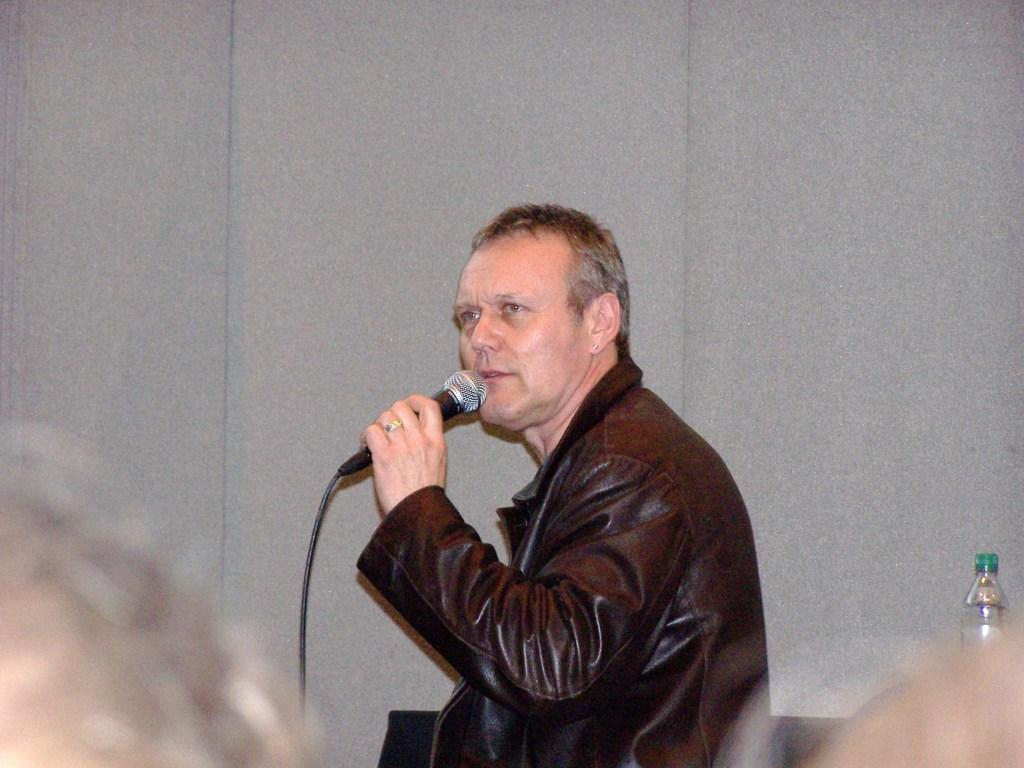Who is present in the image? There is a man in the image. What is the man wearing? The man is wearing a jacket. What object is the man holding in his hand? The man is holding a microphone in his hand. How many sheep can be seen on the island in the image? There are no sheep or islands present in the image; it features a man holding a microphone. What type of spark can be seen coming from the microphone in the image? There is no spark visible in the image; the man is simply holding a microphone. 